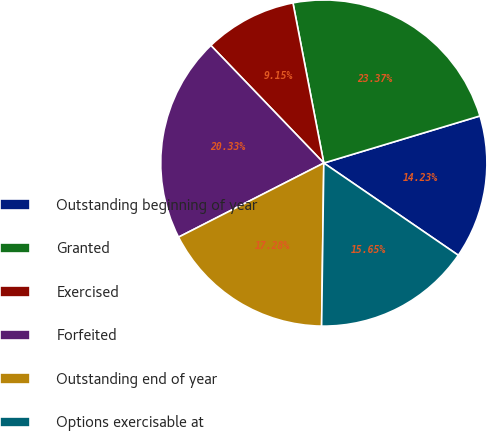Convert chart. <chart><loc_0><loc_0><loc_500><loc_500><pie_chart><fcel>Outstanding beginning of year<fcel>Granted<fcel>Exercised<fcel>Forfeited<fcel>Outstanding end of year<fcel>Options exercisable at<nl><fcel>14.23%<fcel>23.37%<fcel>9.15%<fcel>20.33%<fcel>17.28%<fcel>15.65%<nl></chart> 